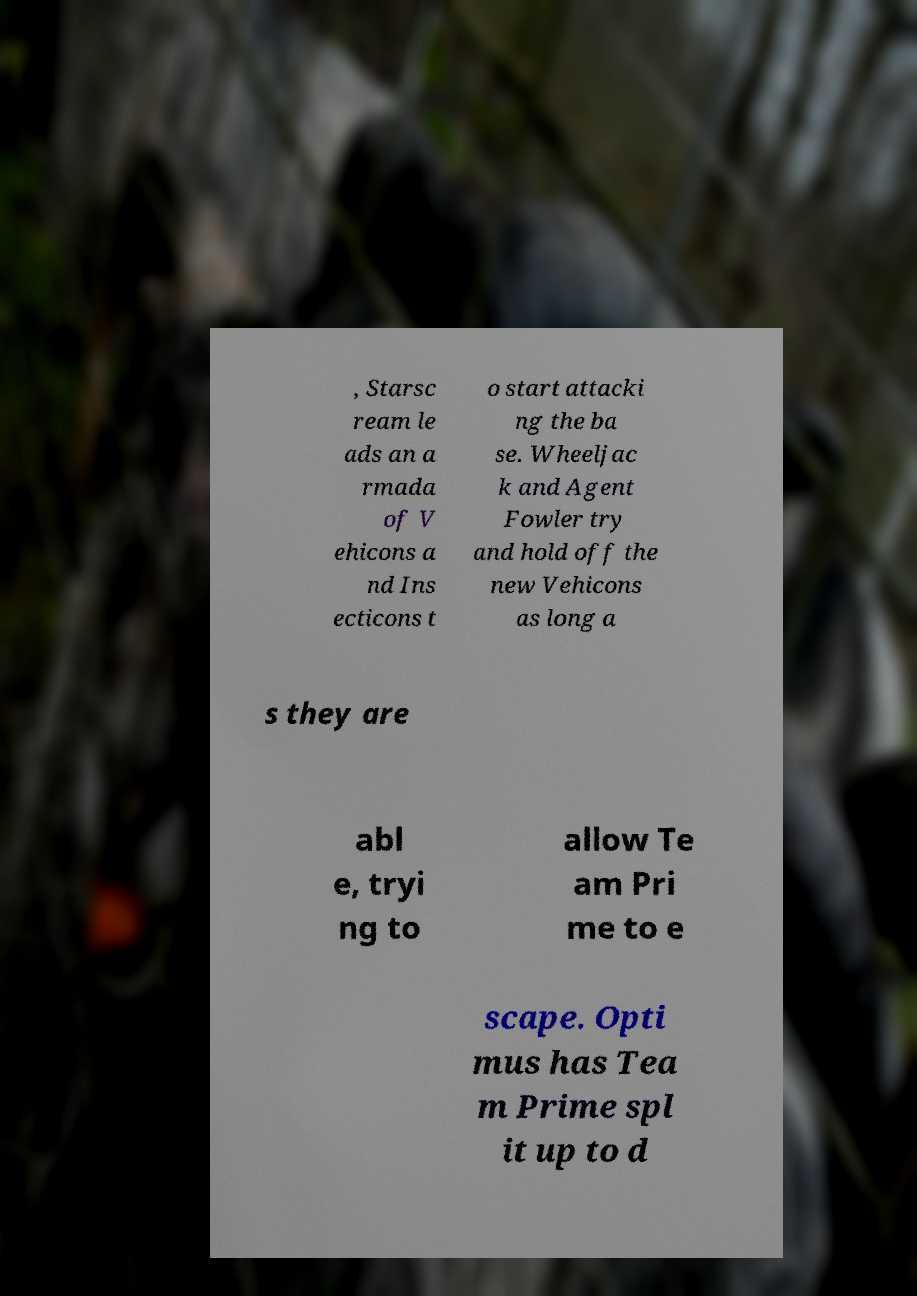Please identify and transcribe the text found in this image. , Starsc ream le ads an a rmada of V ehicons a nd Ins ecticons t o start attacki ng the ba se. Wheeljac k and Agent Fowler try and hold off the new Vehicons as long a s they are abl e, tryi ng to allow Te am Pri me to e scape. Opti mus has Tea m Prime spl it up to d 